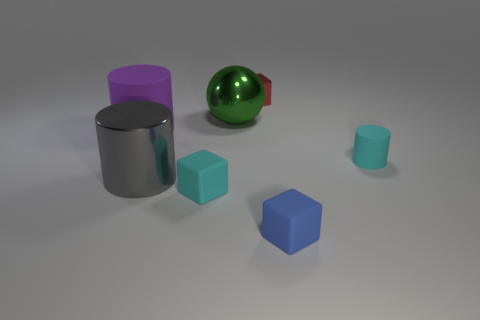Subtract all matte cylinders. How many cylinders are left? 1 Add 3 red metallic cubes. How many objects exist? 10 Subtract 2 cylinders. How many cylinders are left? 1 Subtract all cylinders. How many objects are left? 4 Subtract all brown spheres. How many red cubes are left? 1 Add 1 small red matte objects. How many small red matte objects exist? 1 Subtract 1 gray cylinders. How many objects are left? 6 Subtract all yellow cylinders. Subtract all green cubes. How many cylinders are left? 3 Subtract all cyan rubber cylinders. Subtract all tiny blue rubber objects. How many objects are left? 5 Add 2 big gray cylinders. How many big gray cylinders are left? 3 